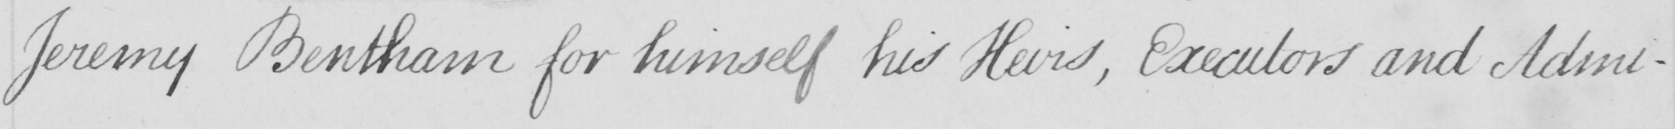Please provide the text content of this handwritten line. Jeremy Bentham for himself his Heirs , Executors and Admi- 